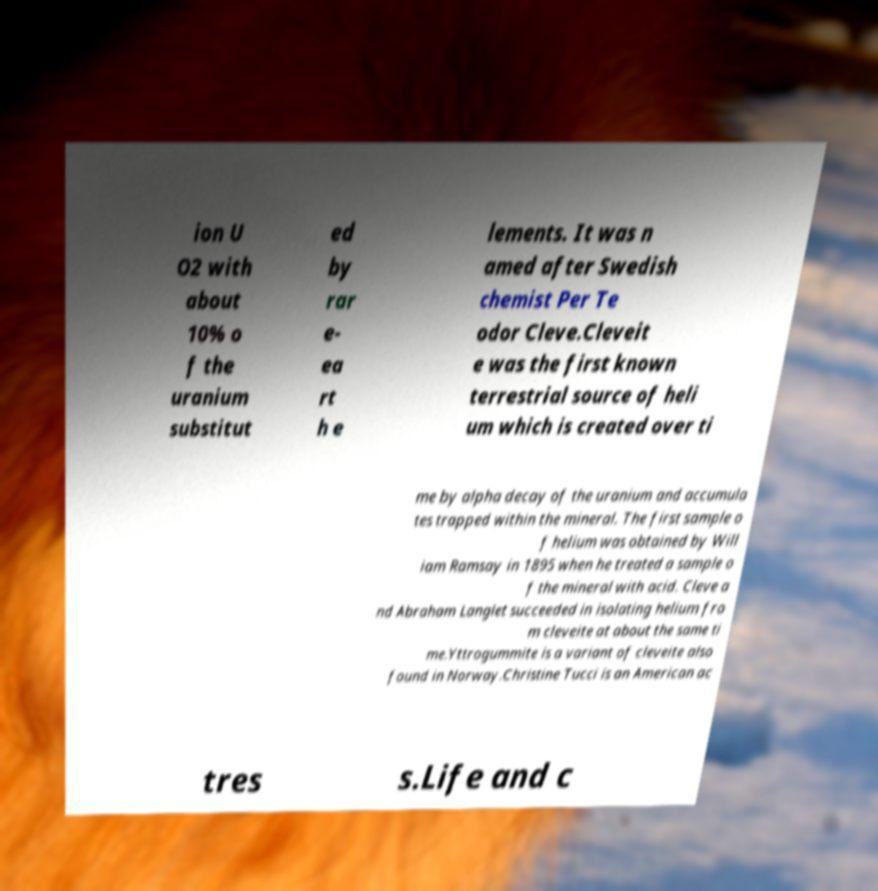Please identify and transcribe the text found in this image. ion U O2 with about 10% o f the uranium substitut ed by rar e- ea rt h e lements. It was n amed after Swedish chemist Per Te odor Cleve.Cleveit e was the first known terrestrial source of heli um which is created over ti me by alpha decay of the uranium and accumula tes trapped within the mineral. The first sample o f helium was obtained by Will iam Ramsay in 1895 when he treated a sample o f the mineral with acid. Cleve a nd Abraham Langlet succeeded in isolating helium fro m cleveite at about the same ti me.Yttrogummite is a variant of cleveite also found in Norway.Christine Tucci is an American ac tres s.Life and c 